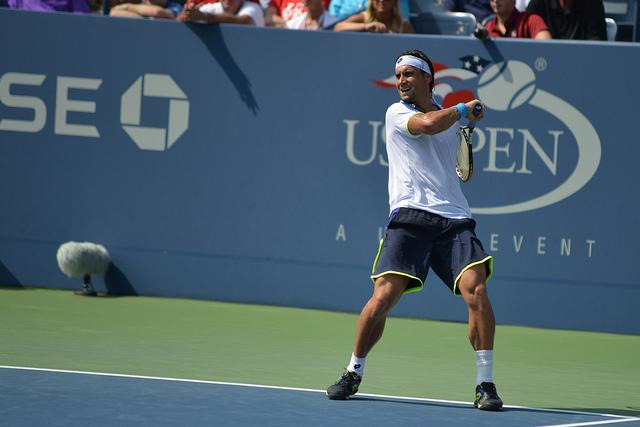Why does he have the racquet behind him? back swing 